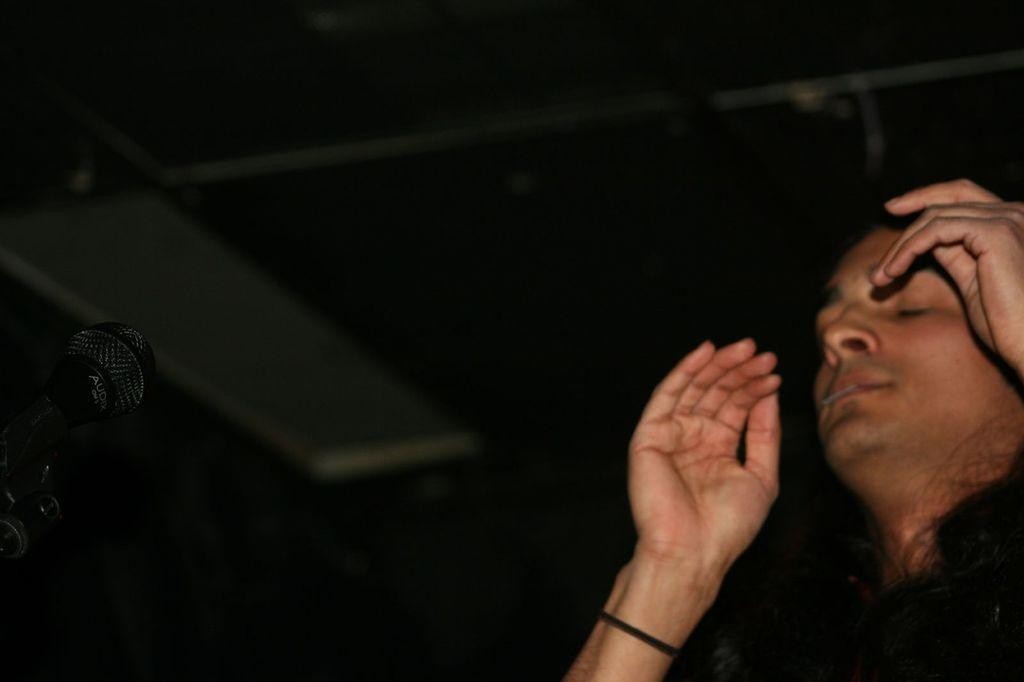What is the main subject of the image? There is a person in the image. What object is the person holding in the image? The person is holding a microphone (mike) in the image. What is the microphone attached to in the image? The microphone is attached to a microphone stand in the image. What can be observed about the lighting in the image? The background of the image is dark. What type of steel is the farmer using to clean the maid's crib in the image? There is no farmer, maid, or crib present in the image. The image features a person holding a microphone and a microphone stand, with a dark background. 